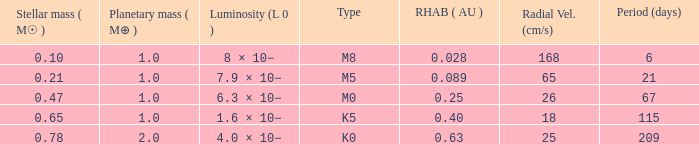What is the total stellar mass of the type m0? 0.47. 